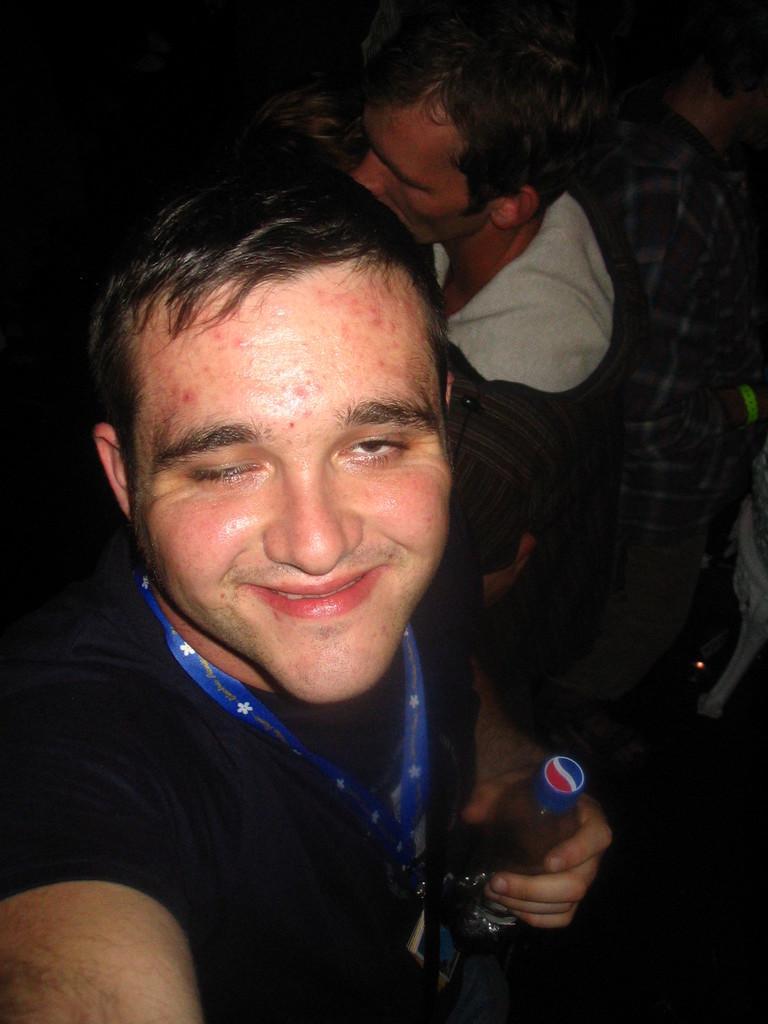How would you summarize this image in a sentence or two? In the image we can see there are people wearing clothes, this person is wearing identity card and holding a bottle in his hand, and he is smiling. 